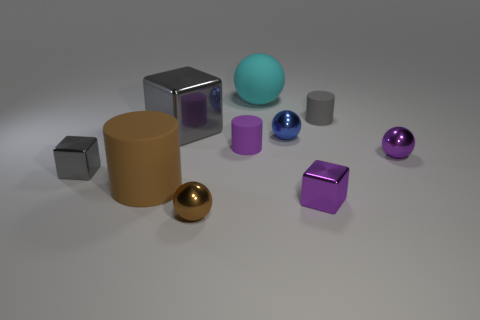Do the brown ball and the large block have the same material?
Offer a very short reply. Yes. What number of large objects are red rubber blocks or purple blocks?
Provide a short and direct response. 0. Are there any other things that are the same shape as the brown shiny object?
Your answer should be compact. Yes. Is there any other thing that is the same size as the purple ball?
Provide a short and direct response. Yes. There is a large ball that is the same material as the big cylinder; what is its color?
Offer a terse response. Cyan. What color is the cylinder right of the cyan matte object?
Make the answer very short. Gray. How many matte spheres have the same color as the large cylinder?
Keep it short and to the point. 0. Are there fewer brown metal objects that are behind the purple cube than blue shiny objects to the left of the small blue metal thing?
Offer a terse response. No. What number of tiny objects are to the left of the large cyan ball?
Provide a succinct answer. 3. Is there a tiny yellow cylinder that has the same material as the cyan ball?
Ensure brevity in your answer.  No. 